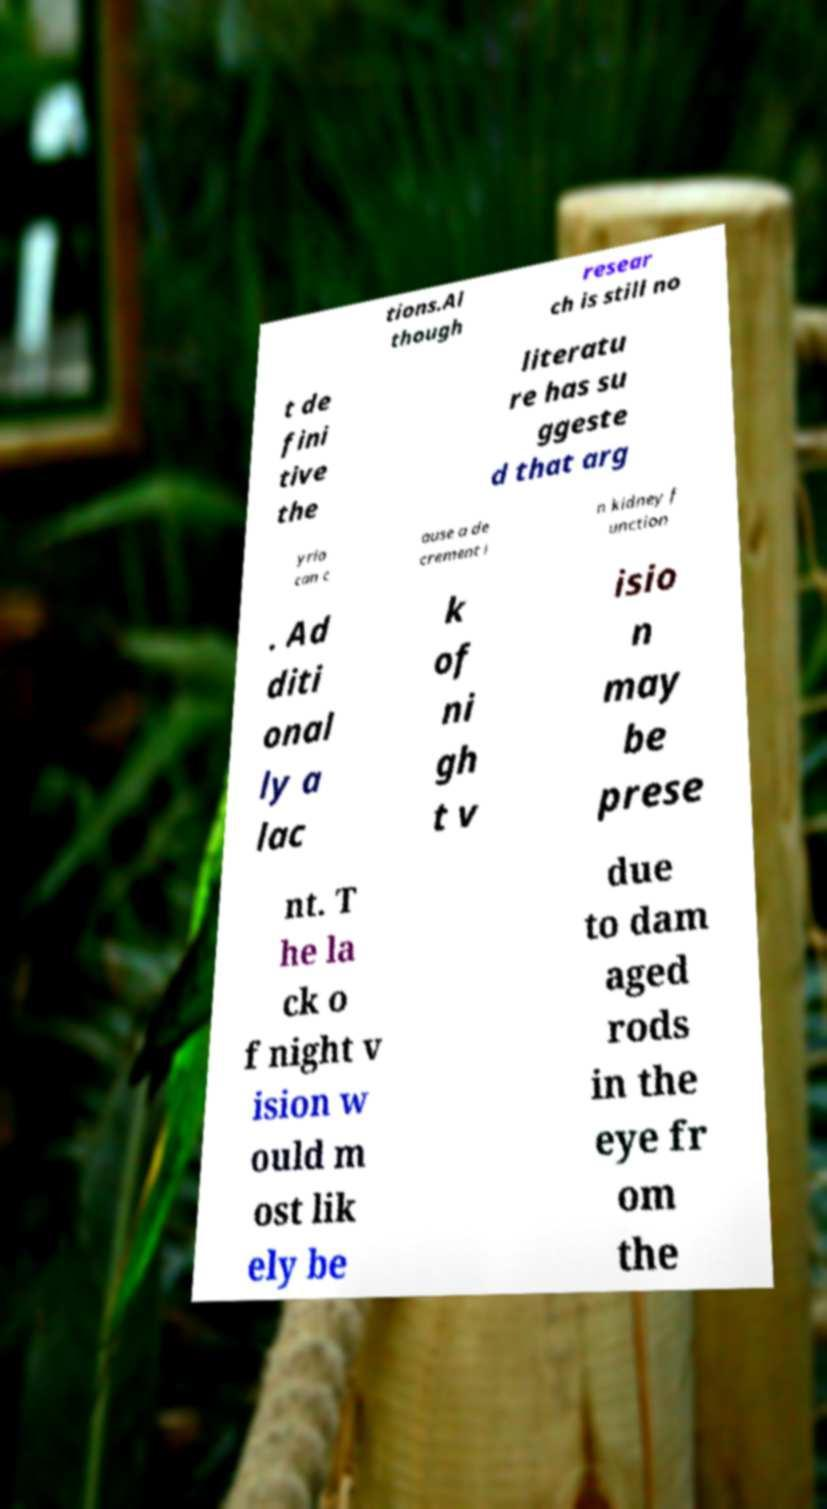I need the written content from this picture converted into text. Can you do that? tions.Al though resear ch is still no t de fini tive the literatu re has su ggeste d that arg yria can c ause a de crement i n kidney f unction . Ad diti onal ly a lac k of ni gh t v isio n may be prese nt. T he la ck o f night v ision w ould m ost lik ely be due to dam aged rods in the eye fr om the 